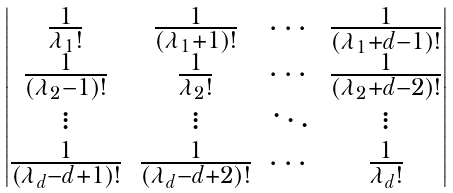<formula> <loc_0><loc_0><loc_500><loc_500>\begin{vmatrix} \frac { 1 } { \lambda _ { 1 } ! } & \frac { 1 } { ( \lambda _ { 1 } + 1 ) ! } & \cdots & \frac { 1 } { ( \lambda _ { 1 } + d - 1 ) ! } \\ \frac { 1 } { ( \lambda _ { 2 } - 1 ) ! } & \frac { 1 } { \lambda _ { 2 } ! } & \cdots & \frac { 1 } { ( \lambda _ { 2 } + d - 2 ) ! } \\ \vdots & \vdots & \ddots & \vdots \\ \frac { 1 } { ( \lambda _ { d } - d + 1 ) ! } & \frac { 1 } { ( \lambda _ { d } - d + 2 ) ! } & \cdots & \frac { 1 } { \lambda _ { d } ! } \end{vmatrix}</formula> 